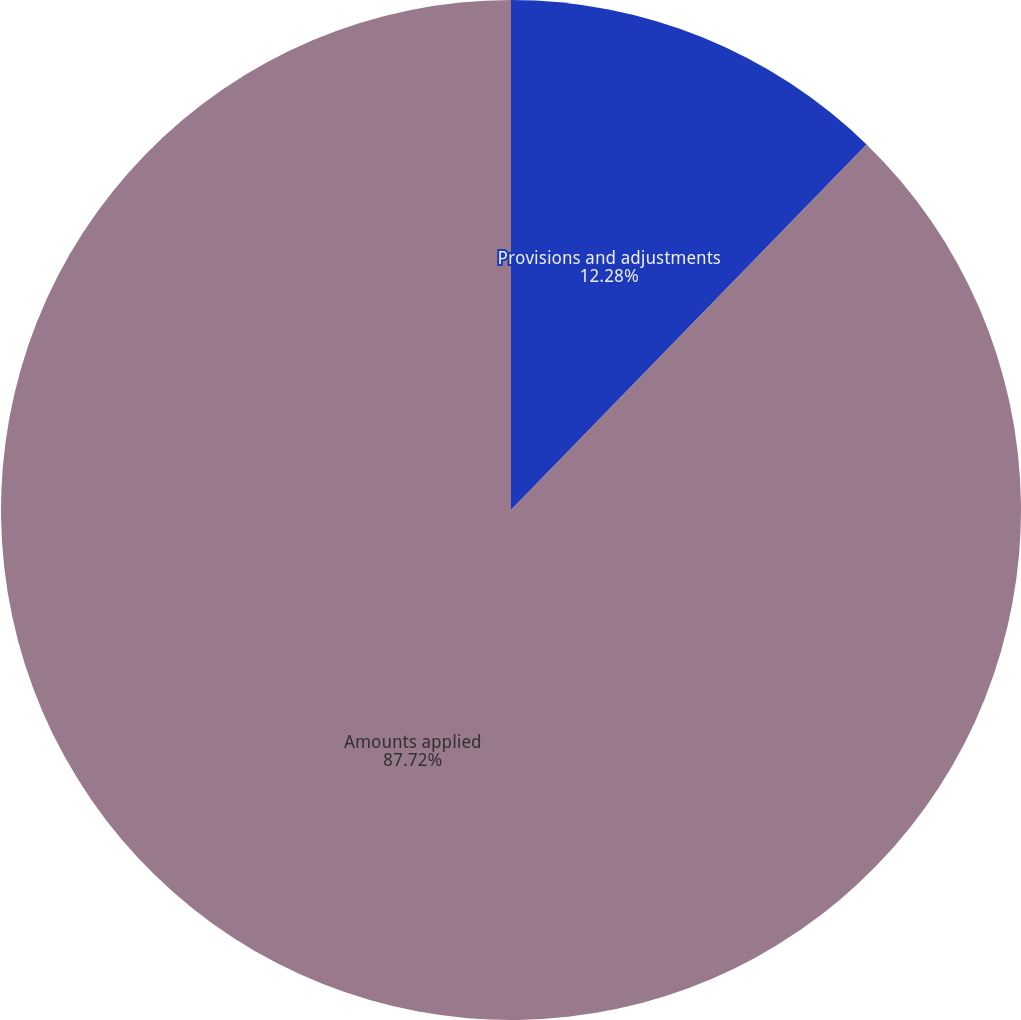<chart> <loc_0><loc_0><loc_500><loc_500><pie_chart><fcel>Provisions and adjustments<fcel>Amounts applied<nl><fcel>12.28%<fcel>87.72%<nl></chart> 